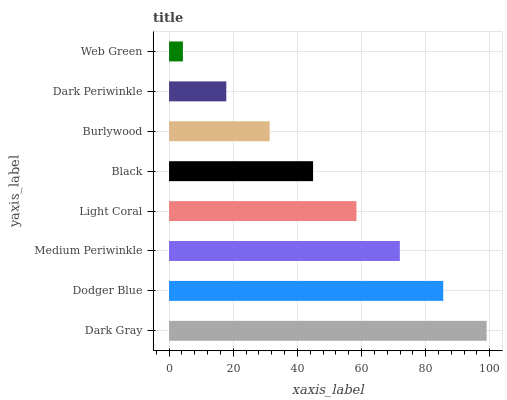Is Web Green the minimum?
Answer yes or no. Yes. Is Dark Gray the maximum?
Answer yes or no. Yes. Is Dodger Blue the minimum?
Answer yes or no. No. Is Dodger Blue the maximum?
Answer yes or no. No. Is Dark Gray greater than Dodger Blue?
Answer yes or no. Yes. Is Dodger Blue less than Dark Gray?
Answer yes or no. Yes. Is Dodger Blue greater than Dark Gray?
Answer yes or no. No. Is Dark Gray less than Dodger Blue?
Answer yes or no. No. Is Light Coral the high median?
Answer yes or no. Yes. Is Black the low median?
Answer yes or no. Yes. Is Dark Gray the high median?
Answer yes or no. No. Is Web Green the low median?
Answer yes or no. No. 